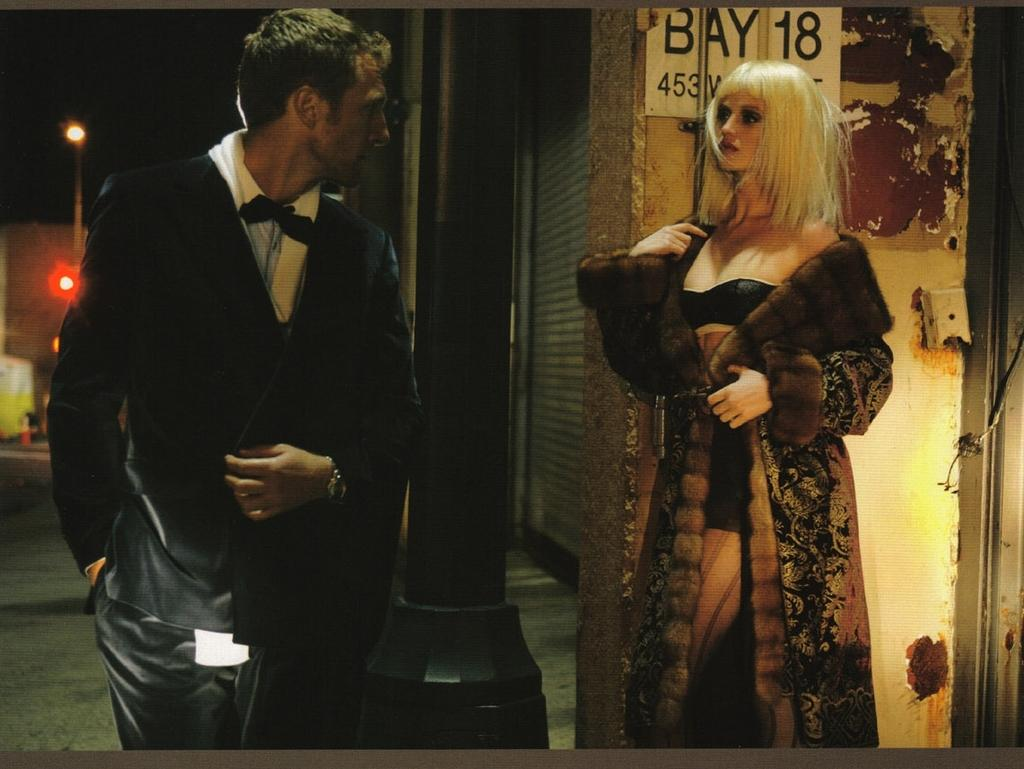How many people are present in the image? There is a man and a woman in the image. What can be seen in the background of the image? There is a light in the background of the image. What type of vein is visible on the woman's forehead in the image? There is no vein visible on the woman's forehead in the image. What town is depicted in the background of the image? The image does not depict a town; it only features a light in the background. 